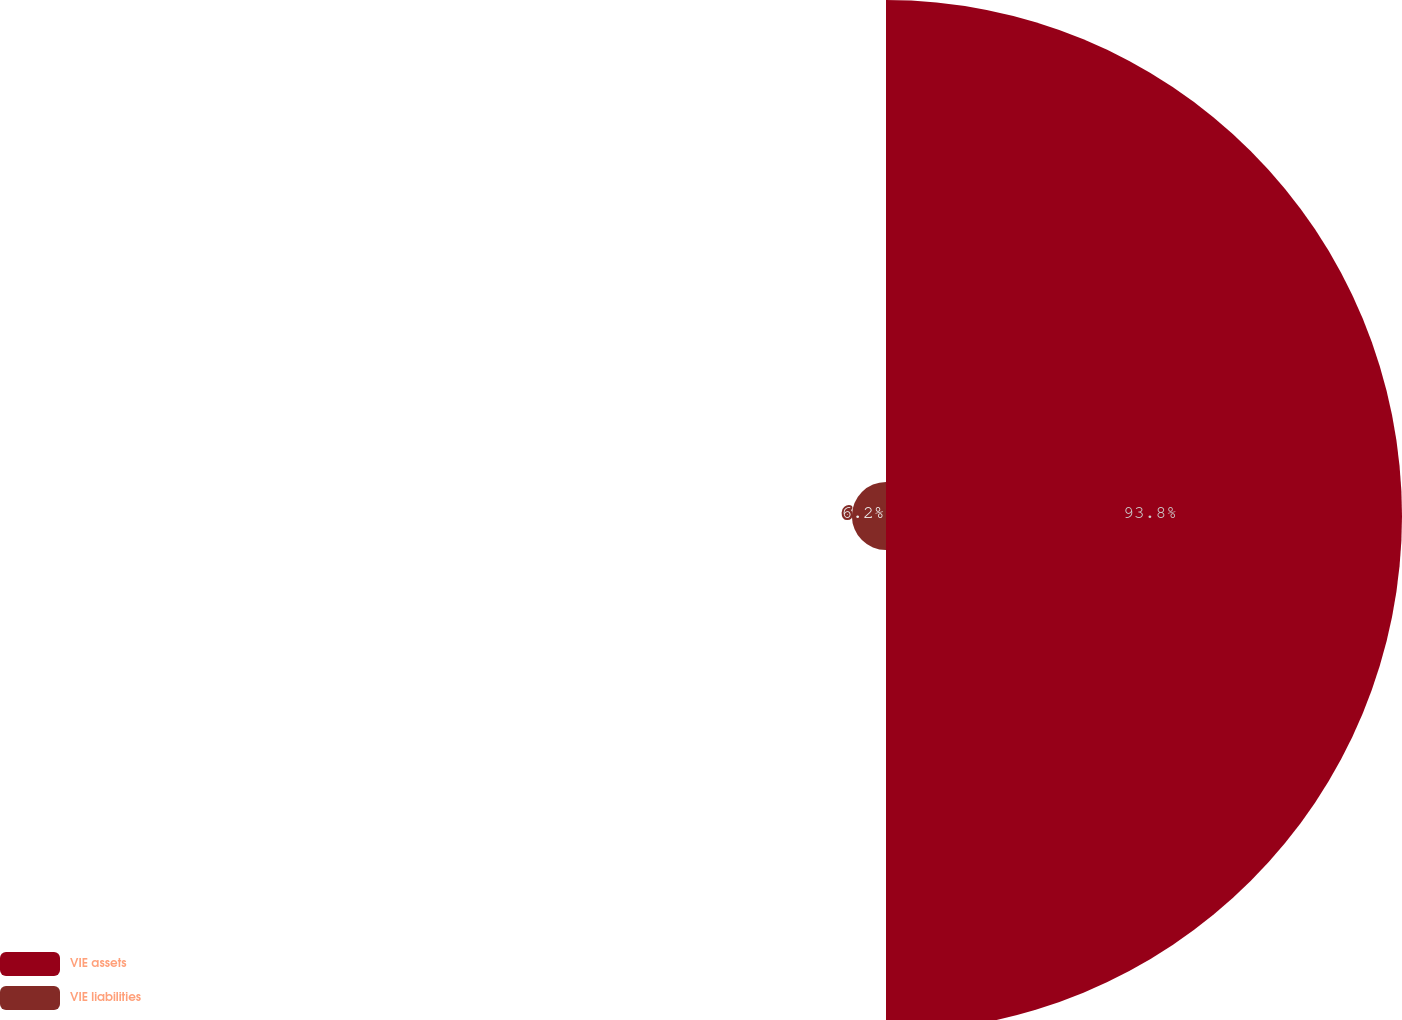Convert chart. <chart><loc_0><loc_0><loc_500><loc_500><pie_chart><fcel>VIE assets<fcel>VIE liabilities<nl><fcel>93.8%<fcel>6.2%<nl></chart> 